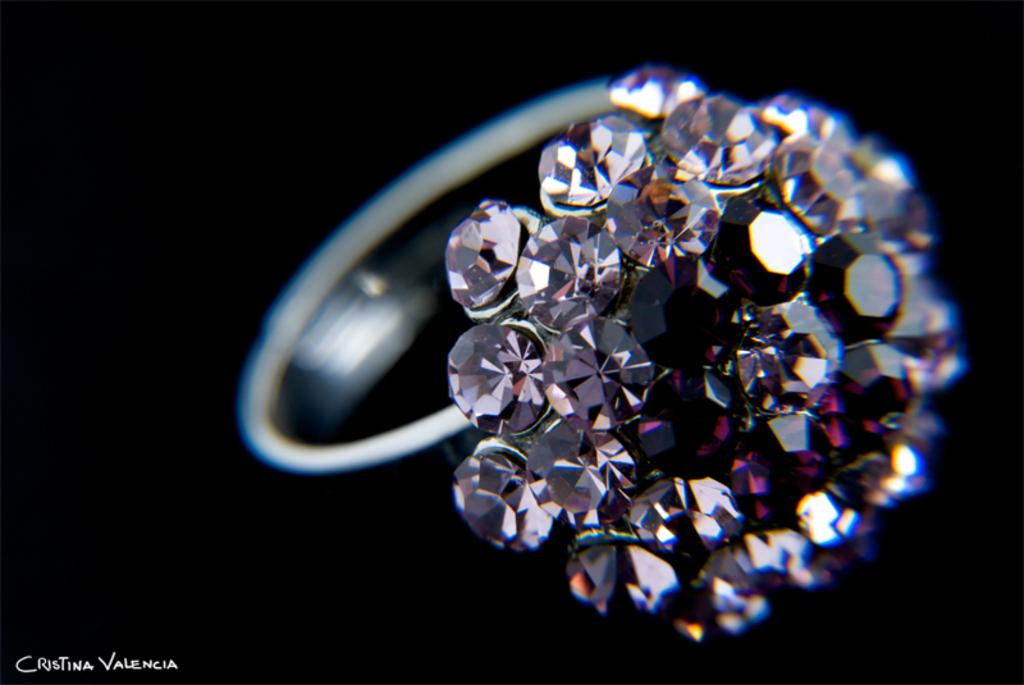What type of jewelry is featured in the image? There is a silver-colored ring in the image. What are the diamonds on the ring like? The diamonds are white and pink in color. What is the color of the ring around the diamonds? The ring is silver-colored. What is the background of the image? The background of the image is black. How many jellyfish can be seen swimming in the background of the image? There are no jellyfish present in the image; the background is black. 